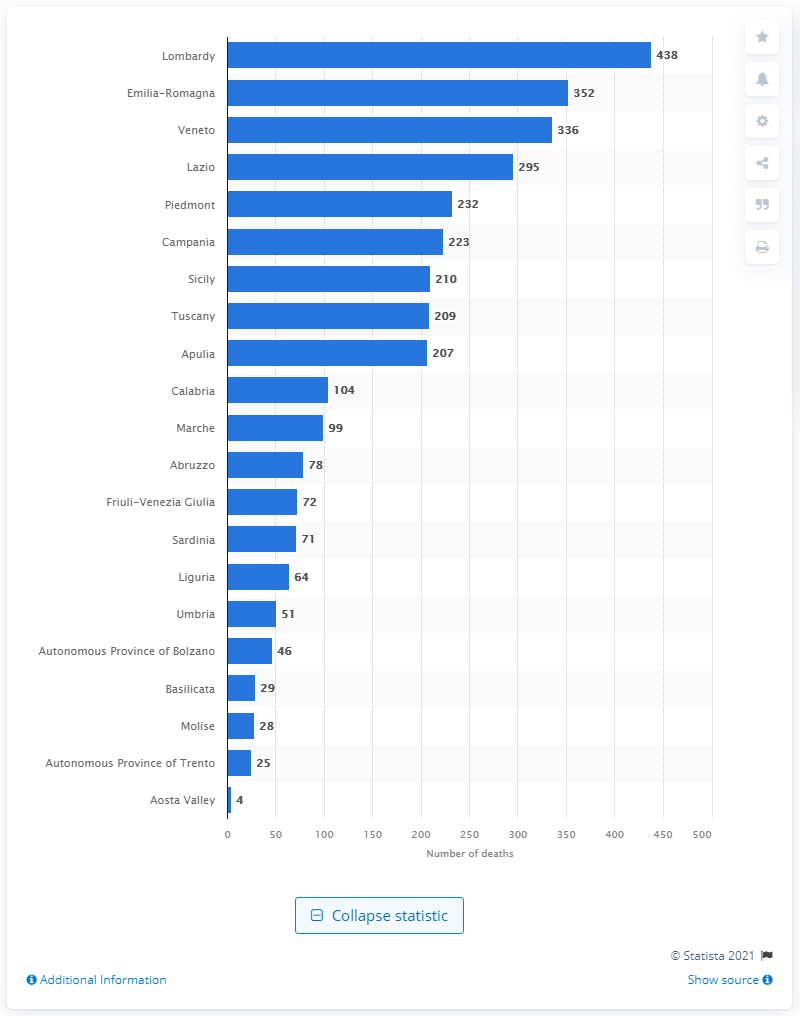List a handful of essential elements in this visual. There were 438 deaths in Lombardy in 2019. In 2019, the region of Lombardy in Italy had the highest number of fatal road crashes. In the year 2019, a total of 352 road traffic deaths occurred in the region of Emilia-Romagna. 